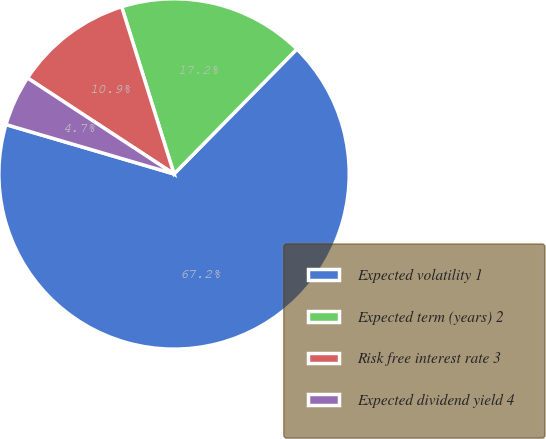Convert chart. <chart><loc_0><loc_0><loc_500><loc_500><pie_chart><fcel>Expected volatility 1<fcel>Expected term (years) 2<fcel>Risk free interest rate 3<fcel>Expected dividend yield 4<nl><fcel>67.18%<fcel>17.2%<fcel>10.94%<fcel>4.68%<nl></chart> 